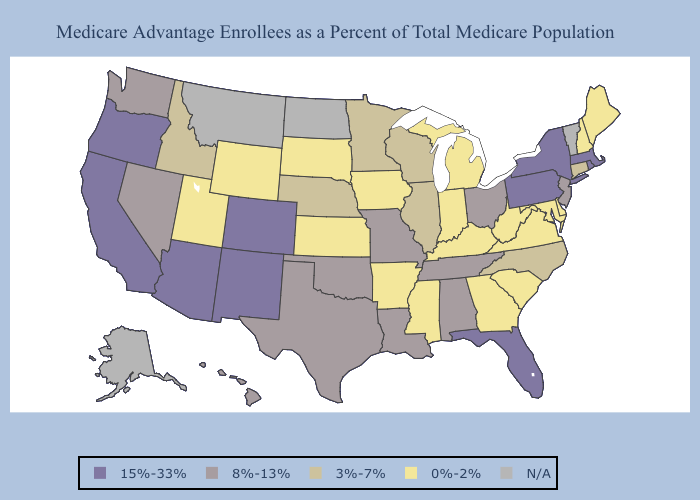Name the states that have a value in the range 15%-33%?
Be succinct. Arizona, California, Colorado, Florida, Massachusetts, New Mexico, New York, Oregon, Pennsylvania, Rhode Island. Does Connecticut have the lowest value in the Northeast?
Be succinct. No. Name the states that have a value in the range N/A?
Write a very short answer. Alaska, Montana, North Dakota, Vermont. What is the value of Florida?
Be succinct. 15%-33%. Which states have the lowest value in the South?
Answer briefly. Arkansas, Delaware, Georgia, Kentucky, Maryland, Mississippi, South Carolina, Virginia, West Virginia. What is the value of Maine?
Give a very brief answer. 0%-2%. Among the states that border Pennsylvania , does Ohio have the highest value?
Give a very brief answer. No. Is the legend a continuous bar?
Answer briefly. No. Name the states that have a value in the range 0%-2%?
Keep it brief. Arkansas, Delaware, Georgia, Iowa, Indiana, Kansas, Kentucky, Maryland, Maine, Michigan, Mississippi, New Hampshire, South Carolina, South Dakota, Utah, Virginia, West Virginia, Wyoming. Which states have the lowest value in the West?
Write a very short answer. Utah, Wyoming. What is the value of Nevada?
Write a very short answer. 8%-13%. What is the lowest value in the MidWest?
Quick response, please. 0%-2%. 